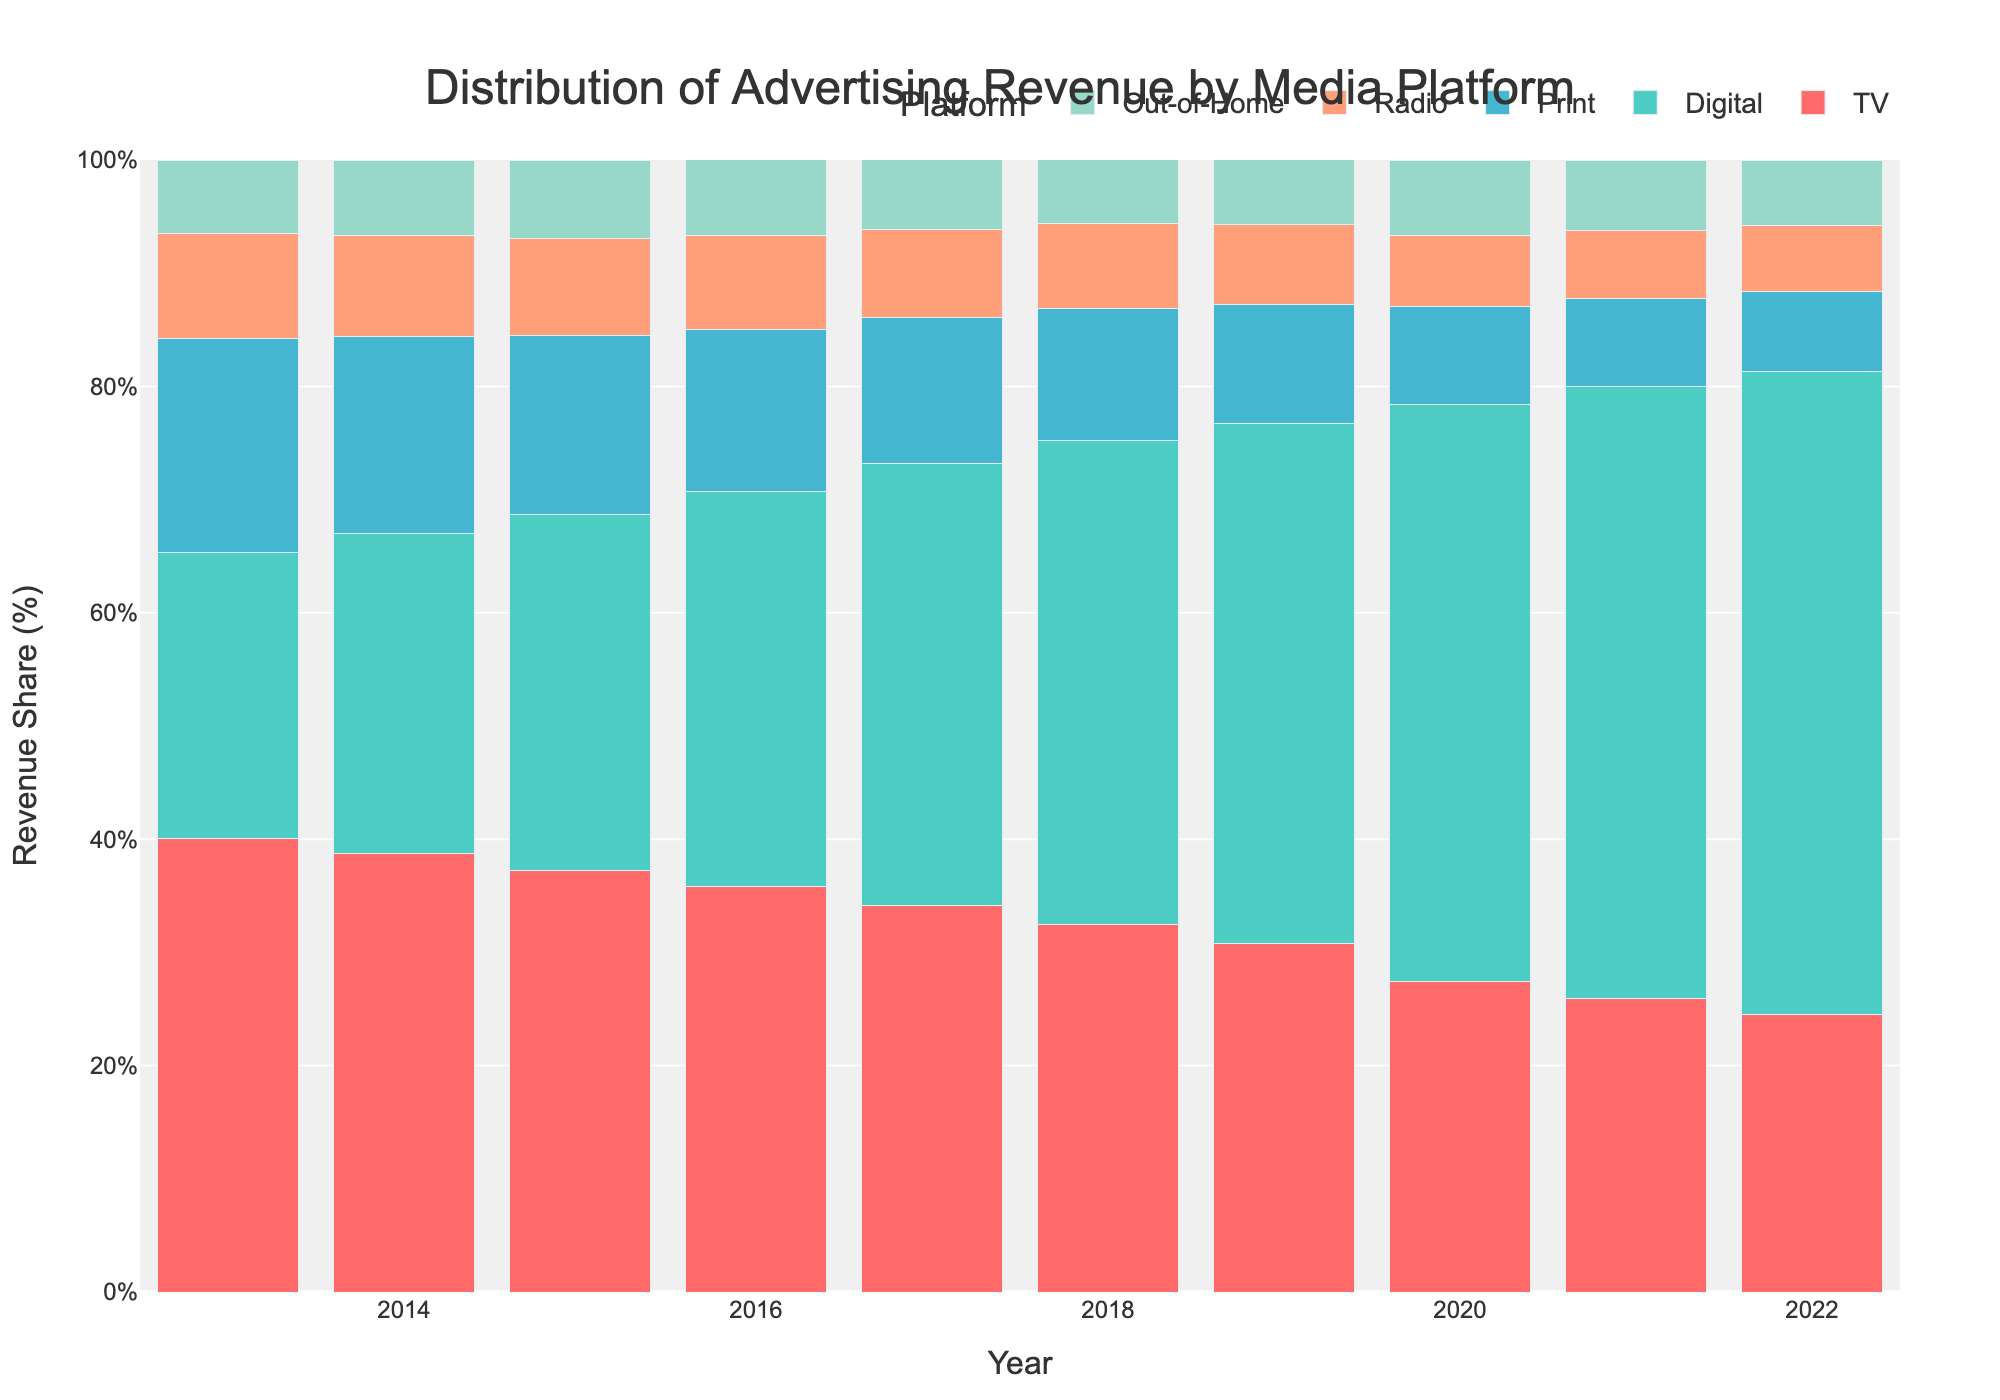What media platform shows the largest increase in revenue share from 2013 to 2022? To determine the platform with the largest increase in revenue share, subtract the revenue share in 2013 from the revenue share in 2022 for each platform. The largest difference will indicate the platform with the highest increase. Digital advertising grows from 25.2% in 2013 to 56.8% in 2022, which is an increase of 31.6 percentage points.
Answer: Digital Which media platform has the smallest share of revenue in 2022? To find out the platform with the smallest share of revenue in 2022, look at the heights of the bars for each platform in that year, noting the smallest percentage. In 2022, Print has the smallest share at 7.1%.
Answer: Print By how much did TV's revenue share decrease from 2013 to 2022? Subtract TV's revenue share in 2022 from its revenue share in 2013. The decrease is 40.1% (2013) - 24.5% (2022) = 15.6 percentage points.
Answer: 15.6 percentage points Which platforms had a consistent increase in revenue share over the decade? Identify platforms that show an upward trend in their revenue share from 2013 to 2022. Digital is the only platform that consistently increased each year.
Answer: Digital In which year did Digital surpass TV in revenue share? To find the year when Digital surpassed TV, look for the first year where the bar for Digital is taller than the bar for TV. This occurs in 2017 when Digital is at 39.1% and TV is at 34.1%.
Answer: 2017 Compare the combined revenue share of Print and Radio in 2022 with their combined share in 2013. By how many percentage points did it change? Calculate the combined share for Print and Radio in both years and then determine the difference. In 2013, Print was 18.9% and Radio was 9.3%, together making 28.2%. In 2022, Print was 7.1% and Radio 5.8%, together making 12.9%. The change is 28.2% - 12.9% = 15.3 percentage points.
Answer: 15.3 percentage points Which platform's revenue share was closest to 10% in 2015? Check the revenue shares of all platforms in 2015 and find the one closest to 10%. Print had 15.8%, Radio had 8.6%, and Out-of-Home had 6.9% which are closer to 10%. Of these, Radio's 8.6% is the closest.
Answer: Radio How does the total advertising revenue percentage compare across the years? Note the annotations for total revenue each year to compare the values; the total should consistently be 100% each year since it's representing a distribution of total revenue among platforms.
Answer: 100% each year What is the trend in Out-of-Home advertising revenue share from 2013 to 2022? Analyze the heights of the bars for Out-of-Home across the years. The Out-of-Home revenue share shows a slight but stable increase, from 6.5% (2013) to 5.8% (2022), though it fluctuates slightly.
Answer: Slight increase Which year shows the highest percentage for Radio advertising? Look at the Radio bars for each year and note the highest one. The highest percentage was in 2013 with 9.3%.
Answer: 2013 